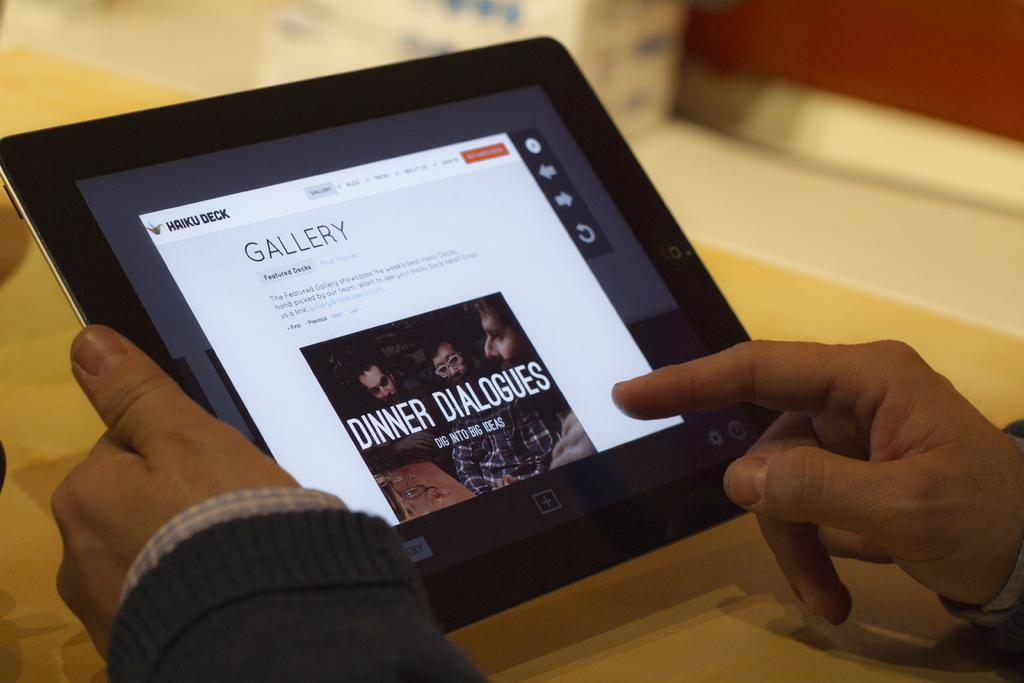What can be seen in the image? There is a person in the image. What part of the person's body is visible? The person's hands are visible. What object is the person holding? The person is carrying a tablet. What is the person doing with the tablet? The person is handling the tablet. What piece of furniture is in front of the person? There is a table in front of the person. How much sugar is on the table in the image? There is no sugar visible on the table in the image. 